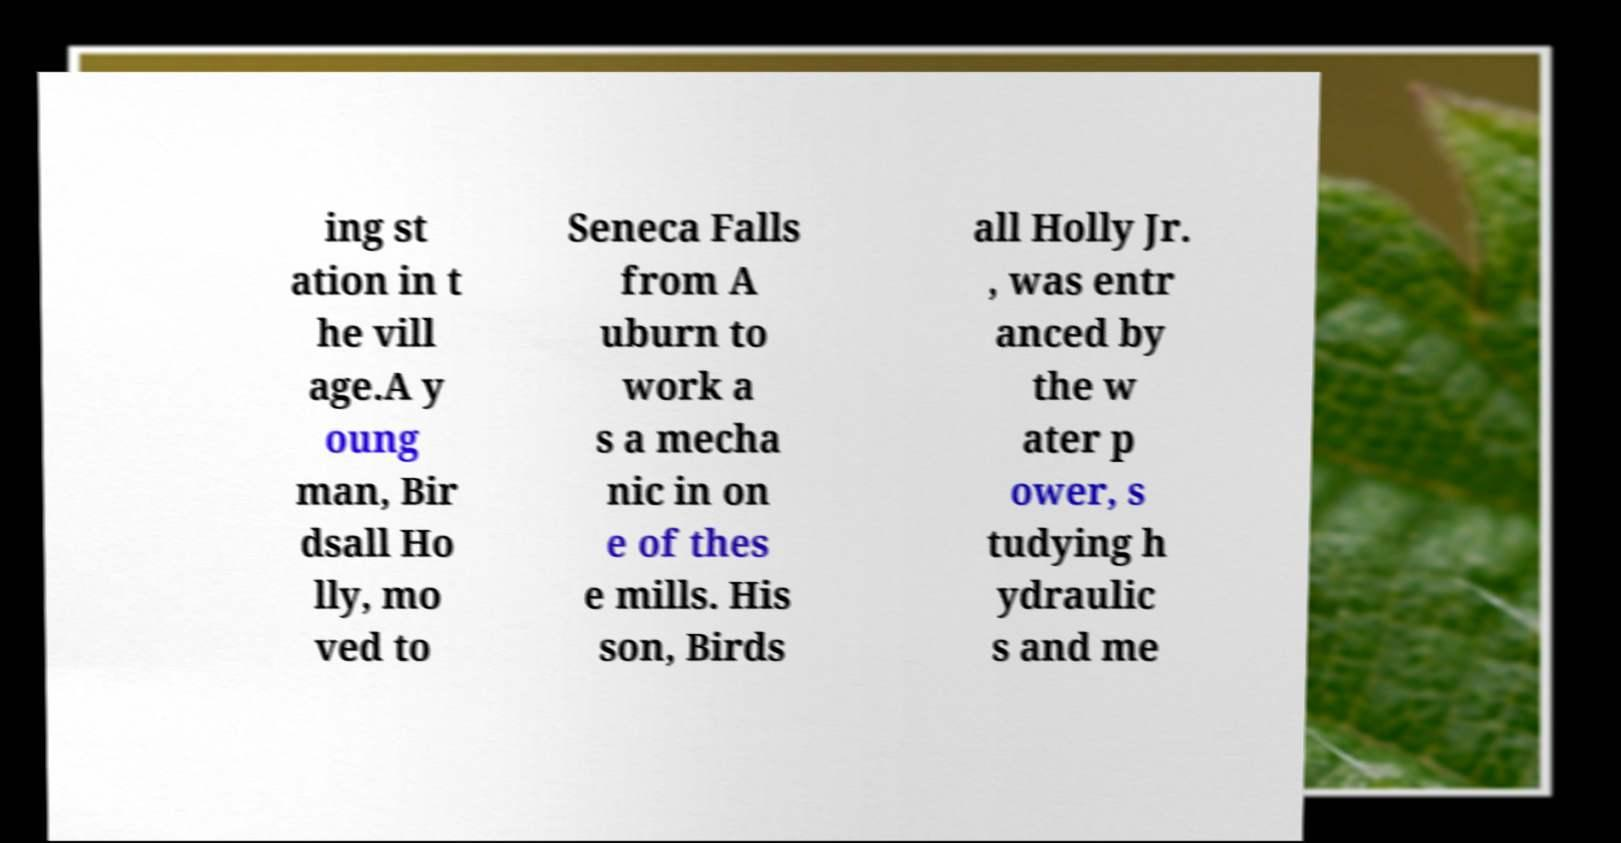What messages or text are displayed in this image? I need them in a readable, typed format. ing st ation in t he vill age.A y oung man, Bir dsall Ho lly, mo ved to Seneca Falls from A uburn to work a s a mecha nic in on e of thes e mills. His son, Birds all Holly Jr. , was entr anced by the w ater p ower, s tudying h ydraulic s and me 